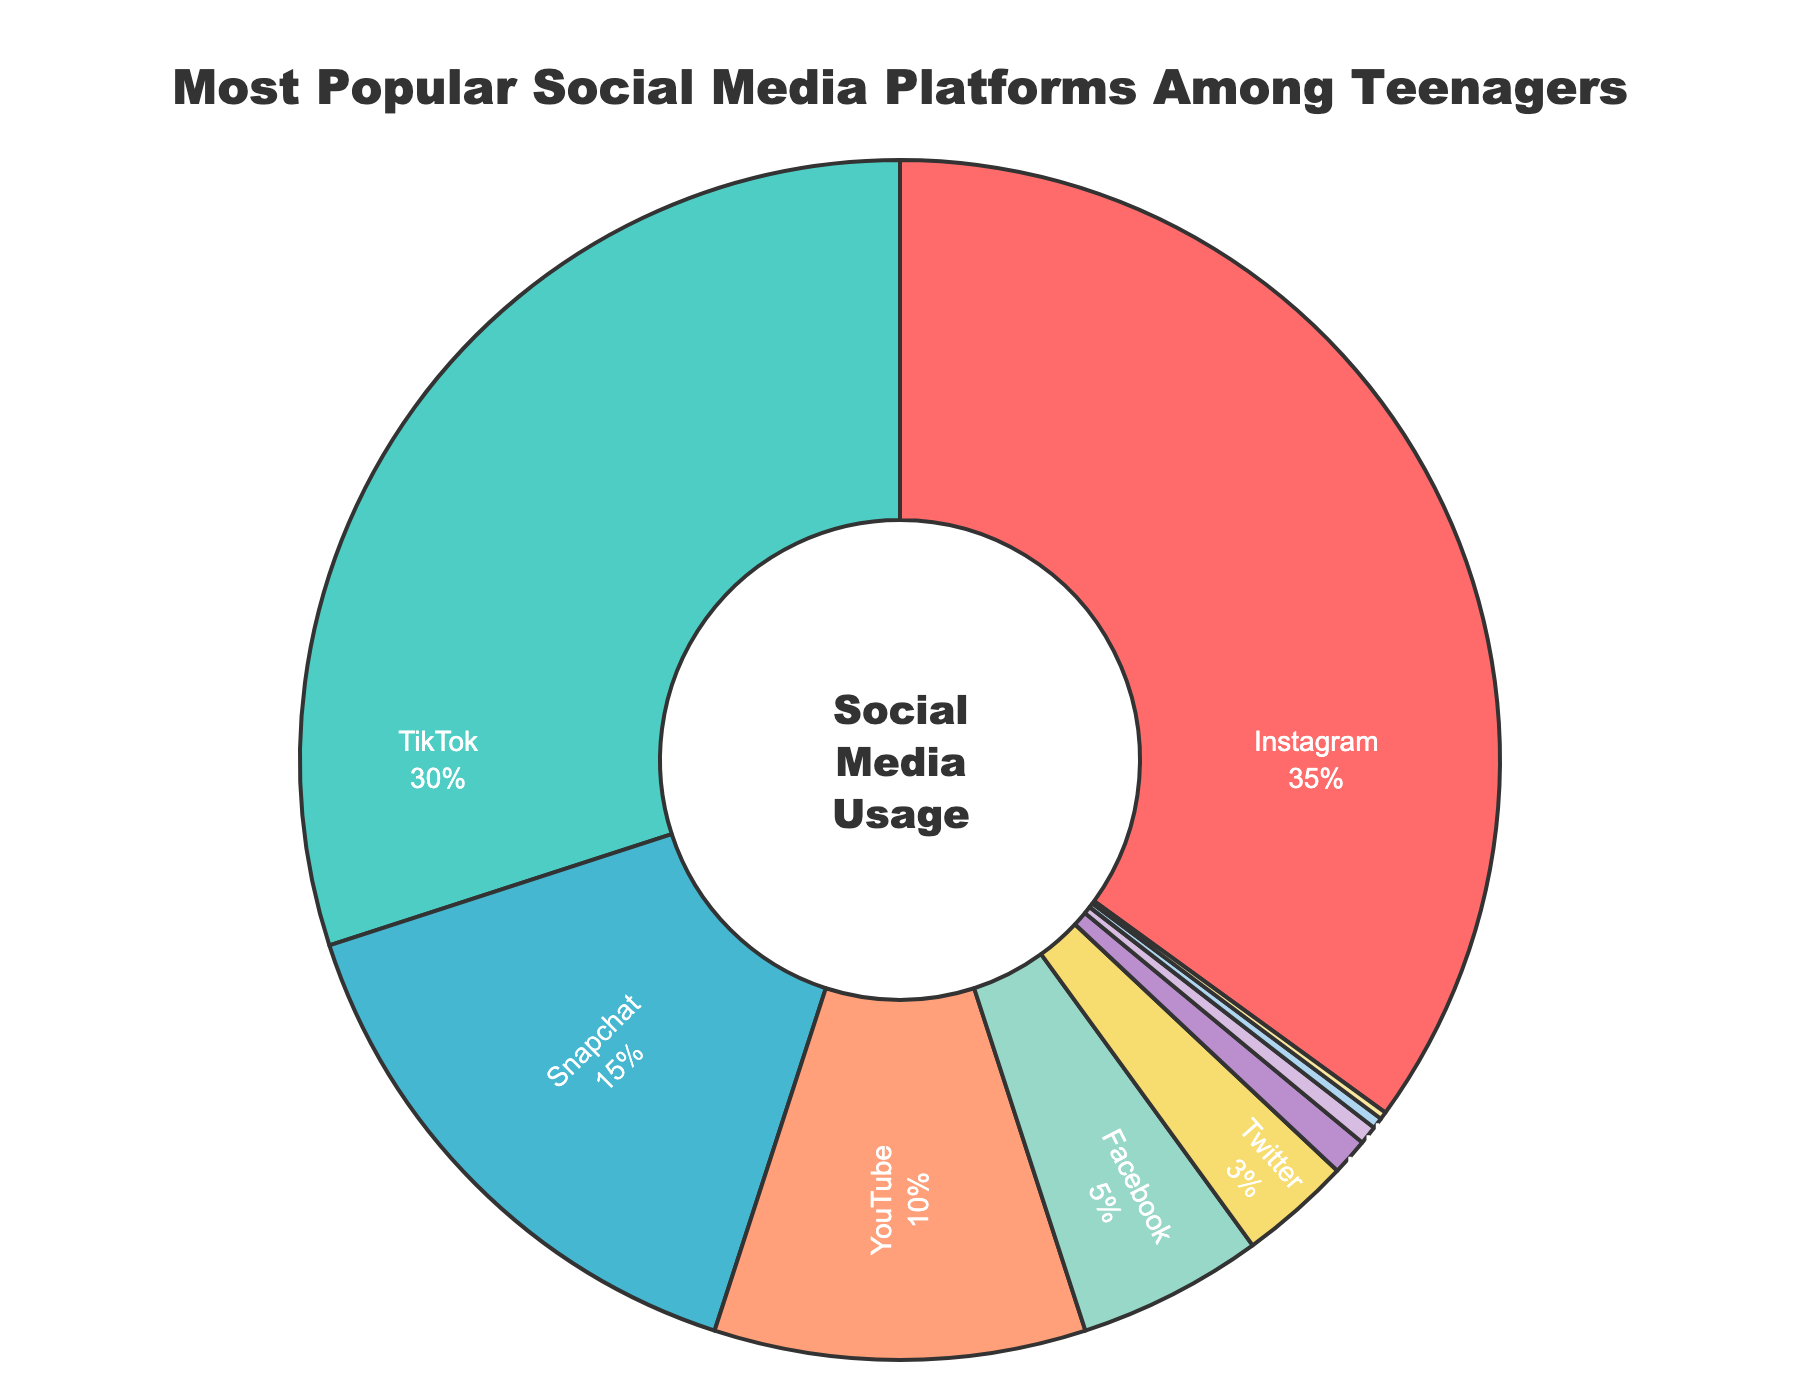Which social media platform is the most popular among teenagers? The pie chart shows that Instagram has the largest segment. With a percentage of 35%, Instagram is the most used platform.
Answer: Instagram Which social media platforms have less than 5% usage among teenagers? Facebook, Twitter, Pinterest, LinkedIn, Reddit, and Tumblr each have percentages below 5% in the pie chart.
Answer: Facebook, Twitter, Pinterest, LinkedIn, Reddit, Tumblr What's the combined percentage of teenagers using Snapchat and YouTube? The pie chart shows Snapchat has 15% and YouTube has 10%. Adding them together gives 15% + 10% = 25%.
Answer: 25% Which is used more among teenagers, TikTok or Snapchat? Checking the pie chart, TikTok has 30%, while Snapchat has 15%. Since 30% is greater than 15%, TikTok is used more.
Answer: TikTok If you combine the usage of the three least popular platforms, what percentage of teenagers use them? LinkedIn, Reddit, and Tumblr have usage percentages of 0.5%, 0.3%, and 0.2%, respectively. Adding them gives 0.5% + 0.3% + 0.2% = 1.0%.
Answer: 1.0% Is the usage of Facebook less than Twitter and Pinterest combined among teenagers? Facebook has 5%, while Twitter and Pinterest have 3% and 1% respectively. Combining Twitter and Pinterest, we get 3% + 1% = 4%. Since 5% is greater than 4%, Facebook is not less.
Answer: No What's the difference in usage percentage between Instagram and YouTube? Instagram has 35% and YouTube has 10%. The difference is 35% - 10% = 25%.
Answer: 25% What is the approximate percentage of teenagers that do not use Instagram, TikTok, or Snapchat? Adding up Instagram (35%), TikTok (30%), and Snapchat (15%), we get 35% + 30% + 15% = 80%. Subtracting from 100%, 100% - 80% = 20%.
Answer: 20% Which social media platform has the second-largest usage among teenagers? The pie chart indicates that TikTok has the second-largest segment with 30%.
Answer: TikTok 